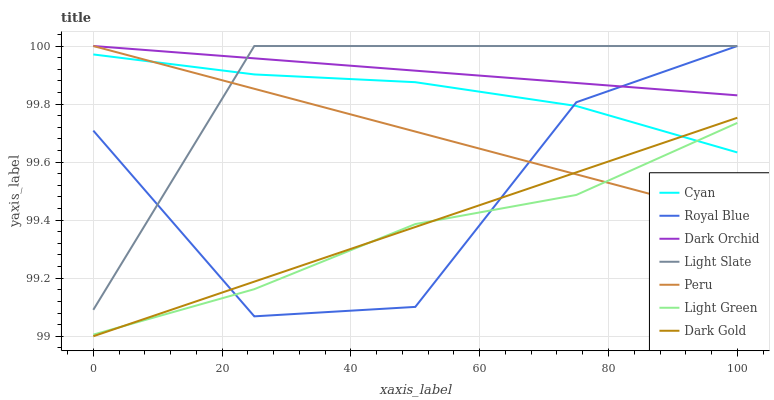Does Light Green have the minimum area under the curve?
Answer yes or no. Yes. Does Dark Orchid have the maximum area under the curve?
Answer yes or no. Yes. Does Dark Gold have the minimum area under the curve?
Answer yes or no. No. Does Dark Gold have the maximum area under the curve?
Answer yes or no. No. Is Dark Orchid the smoothest?
Answer yes or no. Yes. Is Royal Blue the roughest?
Answer yes or no. Yes. Is Dark Gold the smoothest?
Answer yes or no. No. Is Dark Gold the roughest?
Answer yes or no. No. Does Dark Gold have the lowest value?
Answer yes or no. Yes. Does Light Slate have the lowest value?
Answer yes or no. No. Does Royal Blue have the highest value?
Answer yes or no. Yes. Does Dark Gold have the highest value?
Answer yes or no. No. Is Light Green less than Dark Orchid?
Answer yes or no. Yes. Is Light Slate greater than Dark Gold?
Answer yes or no. Yes. Does Light Green intersect Royal Blue?
Answer yes or no. Yes. Is Light Green less than Royal Blue?
Answer yes or no. No. Is Light Green greater than Royal Blue?
Answer yes or no. No. Does Light Green intersect Dark Orchid?
Answer yes or no. No. 